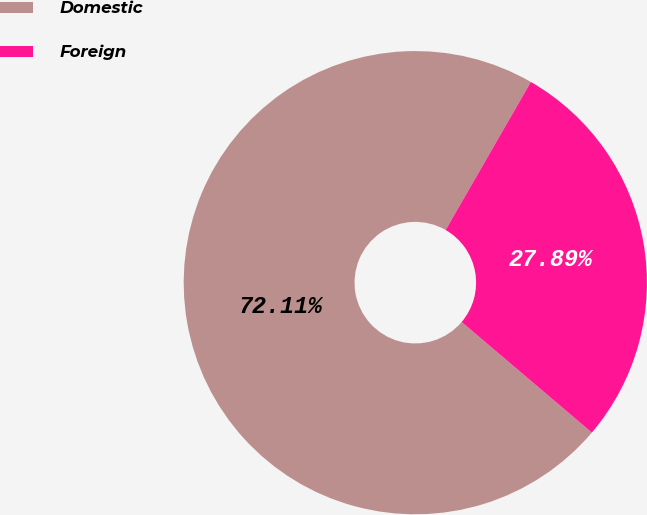Convert chart. <chart><loc_0><loc_0><loc_500><loc_500><pie_chart><fcel>Domestic<fcel>Foreign<nl><fcel>72.11%<fcel>27.89%<nl></chart> 